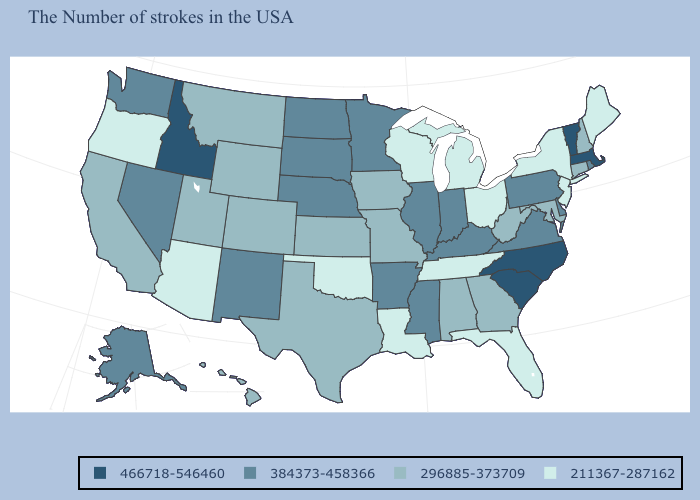Name the states that have a value in the range 384373-458366?
Concise answer only. Rhode Island, Delaware, Pennsylvania, Virginia, Kentucky, Indiana, Illinois, Mississippi, Arkansas, Minnesota, Nebraska, South Dakota, North Dakota, New Mexico, Nevada, Washington, Alaska. Name the states that have a value in the range 296885-373709?
Short answer required. New Hampshire, Connecticut, Maryland, West Virginia, Georgia, Alabama, Missouri, Iowa, Kansas, Texas, Wyoming, Colorado, Utah, Montana, California, Hawaii. What is the value of Oklahoma?
Quick response, please. 211367-287162. Does Washington have a lower value than Vermont?
Keep it brief. Yes. What is the lowest value in states that border Oregon?
Quick response, please. 296885-373709. What is the value of Vermont?
Concise answer only. 466718-546460. Name the states that have a value in the range 211367-287162?
Write a very short answer. Maine, New York, New Jersey, Ohio, Florida, Michigan, Tennessee, Wisconsin, Louisiana, Oklahoma, Arizona, Oregon. Name the states that have a value in the range 384373-458366?
Be succinct. Rhode Island, Delaware, Pennsylvania, Virginia, Kentucky, Indiana, Illinois, Mississippi, Arkansas, Minnesota, Nebraska, South Dakota, North Dakota, New Mexico, Nevada, Washington, Alaska. What is the highest value in the USA?
Keep it brief. 466718-546460. Name the states that have a value in the range 296885-373709?
Give a very brief answer. New Hampshire, Connecticut, Maryland, West Virginia, Georgia, Alabama, Missouri, Iowa, Kansas, Texas, Wyoming, Colorado, Utah, Montana, California, Hawaii. Which states have the lowest value in the USA?
Quick response, please. Maine, New York, New Jersey, Ohio, Florida, Michigan, Tennessee, Wisconsin, Louisiana, Oklahoma, Arizona, Oregon. What is the value of South Carolina?
Short answer required. 466718-546460. Among the states that border Oklahoma , does New Mexico have the lowest value?
Quick response, please. No. Does Georgia have the lowest value in the USA?
Keep it brief. No. 